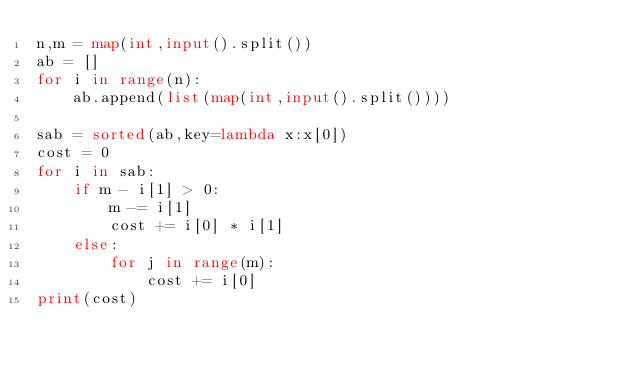<code> <loc_0><loc_0><loc_500><loc_500><_Python_>n,m = map(int,input().split())
ab = []
for i in range(n):
	ab.append(list(map(int,input().split())))
    
sab = sorted(ab,key=lambda x:x[0])
cost = 0
for i in sab:
	if m - i[1] > 0:
		m -= i[1]
		cost += i[0] * i[1]
	else:
		for j in range(m):
			cost += i[0]
print(cost)</code> 